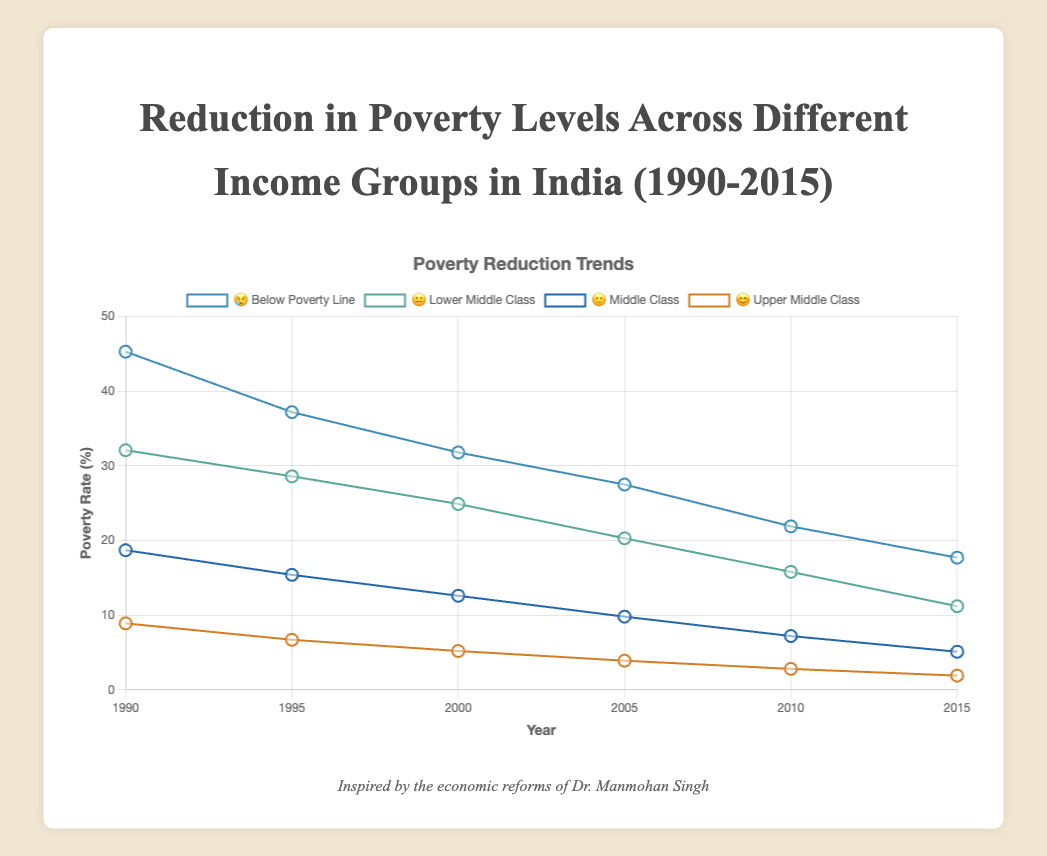what years are displayed in the chart? The x-axis of the chart displays the years indicating when data was collected, which includes 1990, 1995, 2000, 2005, 2010, and 2015.
Answer: 1990, 1995, 2000, 2005, 2010, 2015 which income group has the highest poverty rate in 2000? To find which group has the highest poverty rate in 2000, look for the highest point among the plotted lines at the year 2000. The "Below Poverty Line" group (😢) has a poverty rate of 31.8, which is the highest among all groups.
Answer: Below Poverty Line (😢) what's the trend of poverty rate for the "Lower Middle Class" group (😐) over the years? Over the years 1990 to 2015, the poverty rate for the "Lower Middle Class" group (😐) shows a decreasing trend. Each consecutive year, the poverty rate declines: 32.1, 28.6, 24.9, 20.3, 15.8, and 11.2 percent respectively.
Answer: Decreasing between 2010 and 2015, which group saw the largest reduction in poverty rate? Calculate the reduction by subtracting the 2015 value from the 2010 value for each group. The group "Lower Middle Class" (😐) saw the largest reduction of 4.6% (15.8 - 11.2 = 4.6), compared to 4.2% for "Below Poverty Line" (😢), 2.1% for "Middle Class" (🙂), and 0.9% for "Upper Middle Class" (😊).
Answer: Lower Middle Class (😐) which two groups have a similar poverty rate trend from 1990 to 2015? Compare the trends of all groups over time. The "Middle Class" (🙂) and "Upper Middle Class" (😊) show a similar trend in their poverty rates as both decline steadily and maintain a similar shape across the timeline.
Answer: Middle Class (🙂), Upper Middle Class (😊) by how much did the poverty rate for the "Below Poverty Line" (😢) group decrease from 1990 to 2015? Subtract the poverty rate of the "Below Poverty Line" group in 2015 from its poverty rate in 1990 (45.3 - 17.7 = 27.6). This indicates a decrease by 27.6%.
Answer: 27.6% in which year did the "Upper Middle Class" (😊) group first fall below a poverty rate of 3%? Reviewing the plotted data for the "Upper Middle Class" group, the first year this group's poverty rate falls below 3% is 2010, where it reached 2.8%.
Answer: 2010 how many data points are displayed for the "Middle Class" (🙂) group? Each income group has data points for each year presented. Since there are six years being plotted, there are six data points specifically for the "Middle Class" group.
Answer: 6 